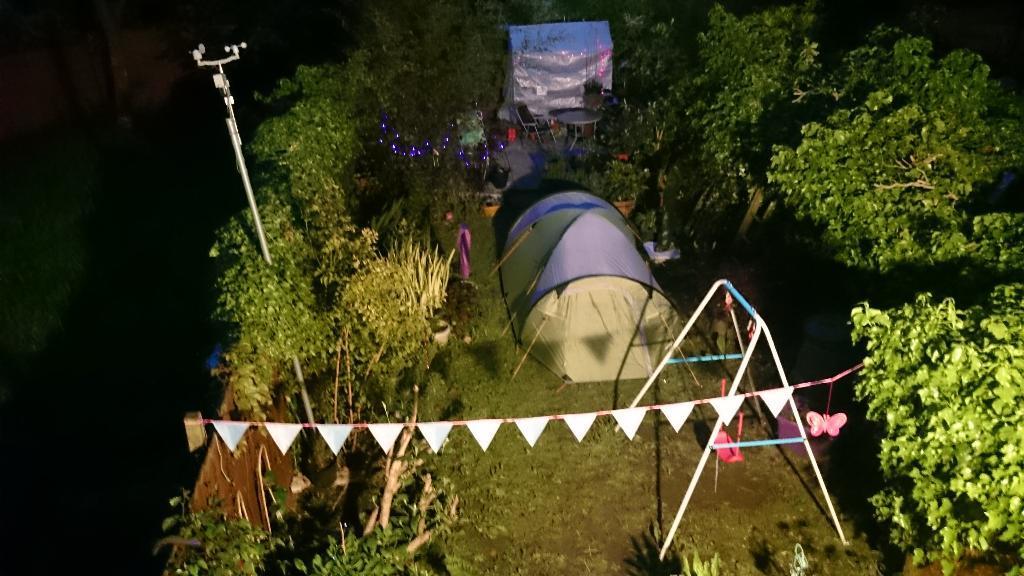How would you summarize this image in a sentence or two? In the foreground of this image, there are bunting flags, swing, two tents, table, chair, lights, flower pots and trees around it. On the left, there is a pole and the background image is dark. 